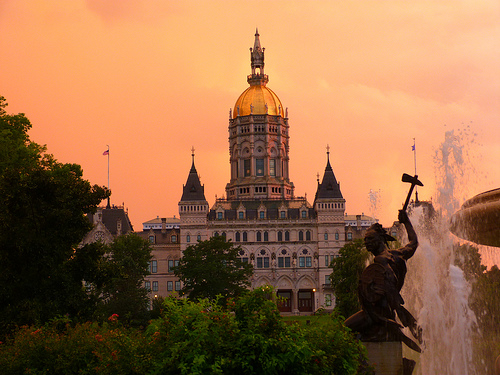<image>
Can you confirm if the statue is next to the building? No. The statue is not positioned next to the building. They are located in different areas of the scene. 